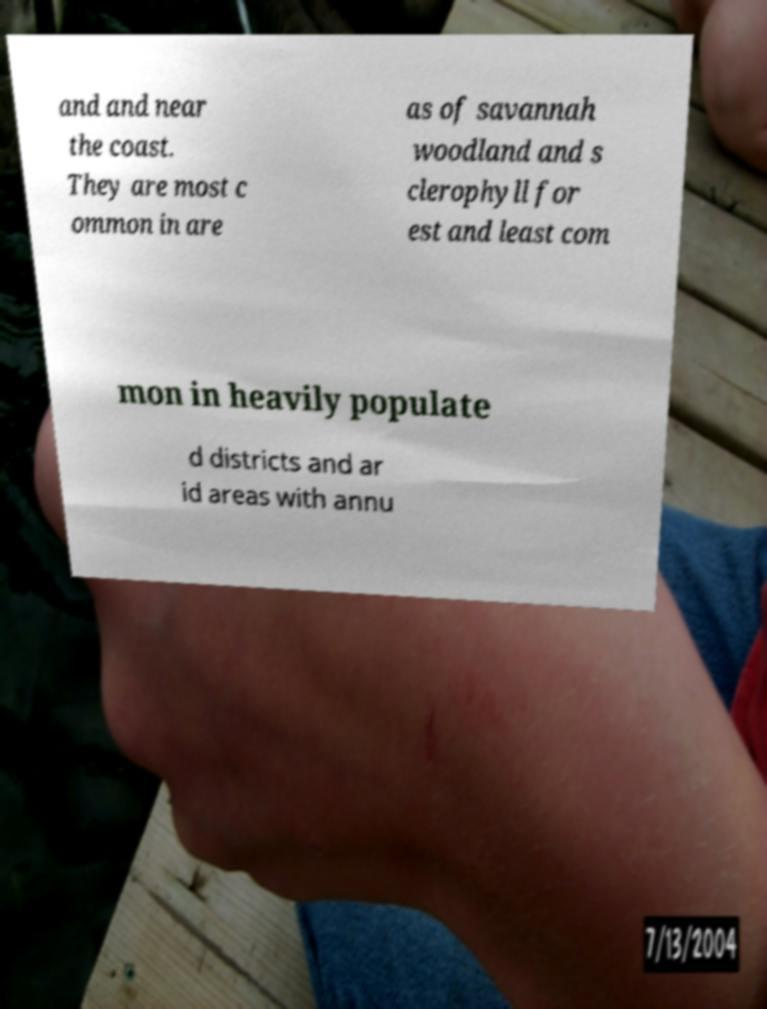Could you extract and type out the text from this image? and and near the coast. They are most c ommon in are as of savannah woodland and s clerophyll for est and least com mon in heavily populate d districts and ar id areas with annu 